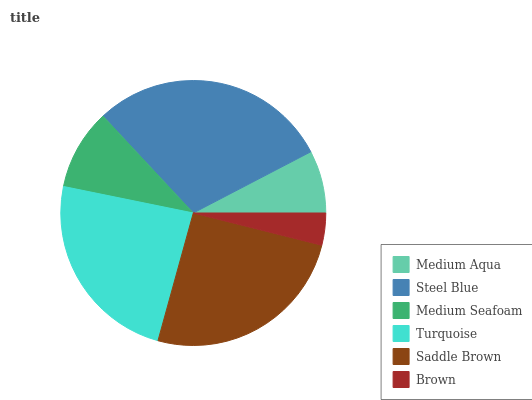Is Brown the minimum?
Answer yes or no. Yes. Is Steel Blue the maximum?
Answer yes or no. Yes. Is Medium Seafoam the minimum?
Answer yes or no. No. Is Medium Seafoam the maximum?
Answer yes or no. No. Is Steel Blue greater than Medium Seafoam?
Answer yes or no. Yes. Is Medium Seafoam less than Steel Blue?
Answer yes or no. Yes. Is Medium Seafoam greater than Steel Blue?
Answer yes or no. No. Is Steel Blue less than Medium Seafoam?
Answer yes or no. No. Is Turquoise the high median?
Answer yes or no. Yes. Is Medium Seafoam the low median?
Answer yes or no. Yes. Is Steel Blue the high median?
Answer yes or no. No. Is Saddle Brown the low median?
Answer yes or no. No. 